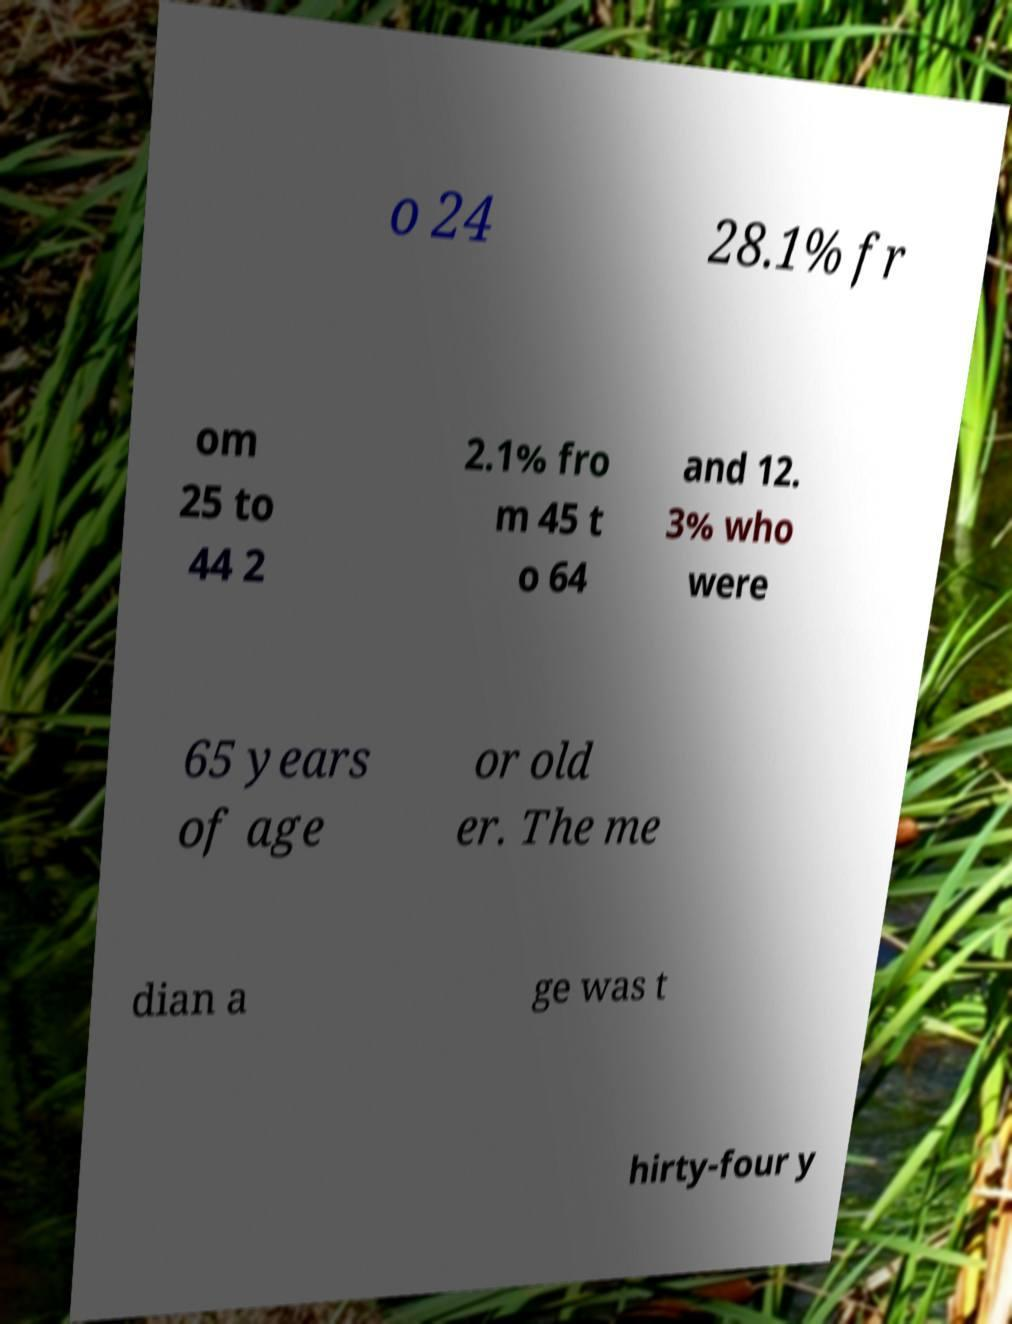Could you extract and type out the text from this image? o 24 28.1% fr om 25 to 44 2 2.1% fro m 45 t o 64 and 12. 3% who were 65 years of age or old er. The me dian a ge was t hirty-four y 